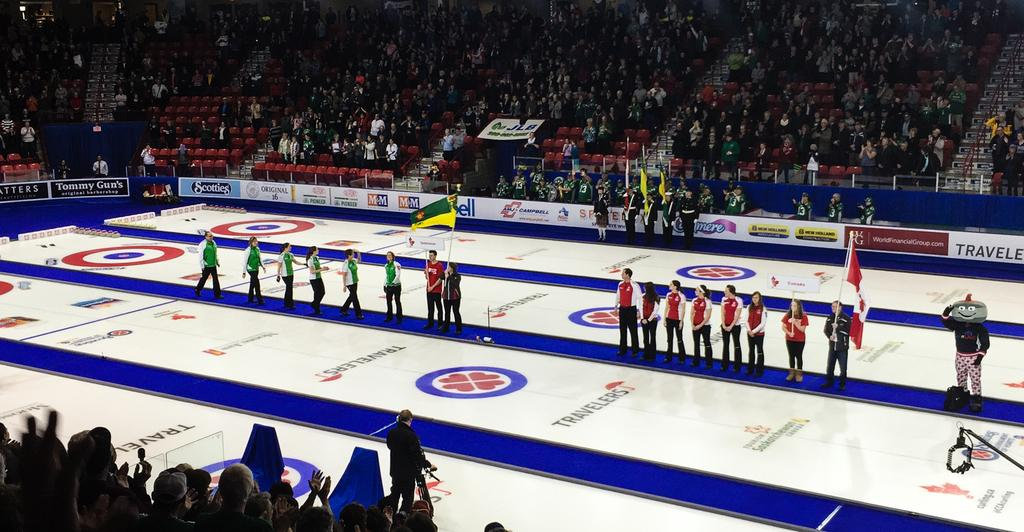<image>
Write a terse but informative summary of the picture. People standing on a floor that advertises for Travelers in front of stands filled with people. 